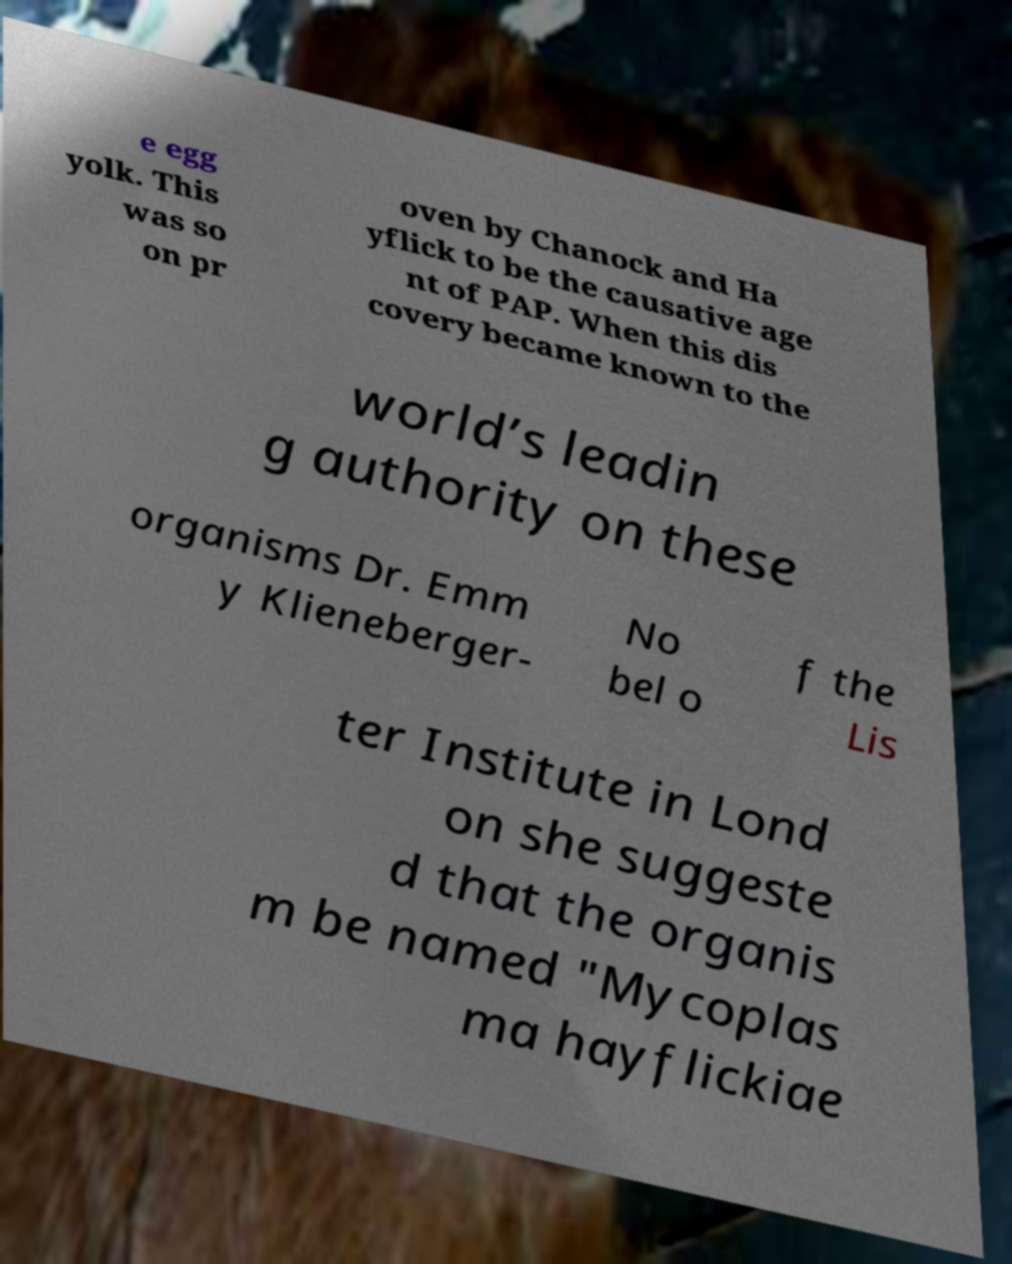Can you read and provide the text displayed in the image?This photo seems to have some interesting text. Can you extract and type it out for me? e egg yolk. This was so on pr oven by Chanock and Ha yflick to be the causative age nt of PAP. When this dis covery became known to the world’s leadin g authority on these organisms Dr. Emm y Klieneberger- No bel o f the Lis ter Institute in Lond on she suggeste d that the organis m be named "Mycoplas ma hayflickiae 